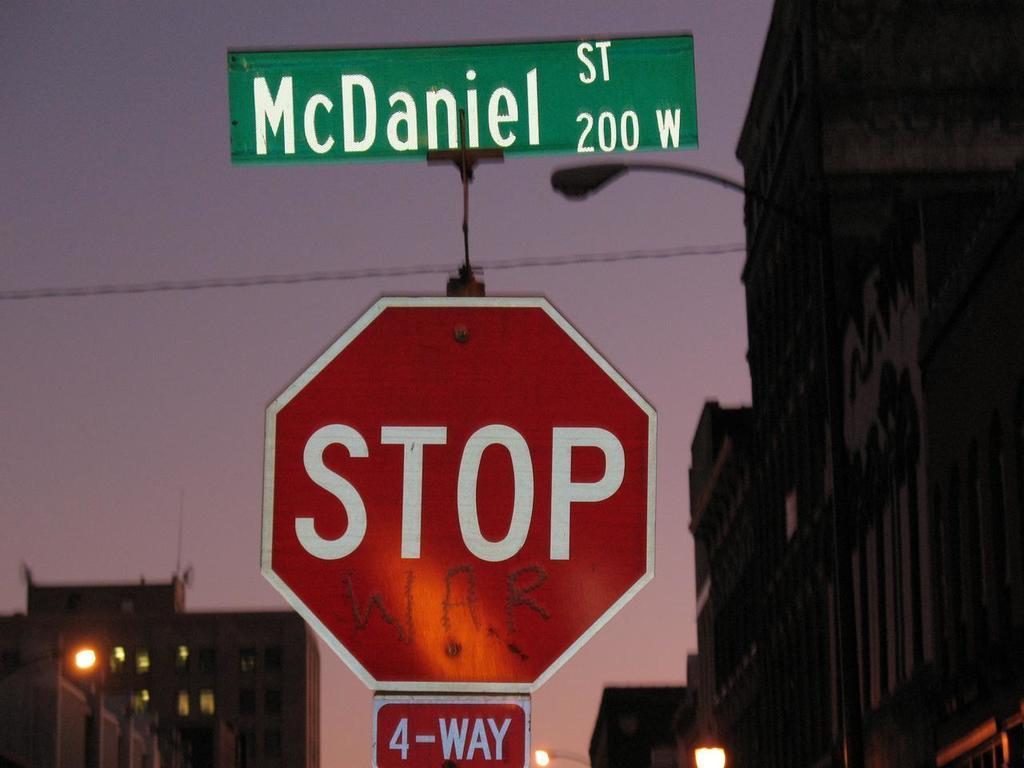Provide a one-sentence caption for the provided image. Three signs on the street named McDaniel St., stop sign with 4-way. 